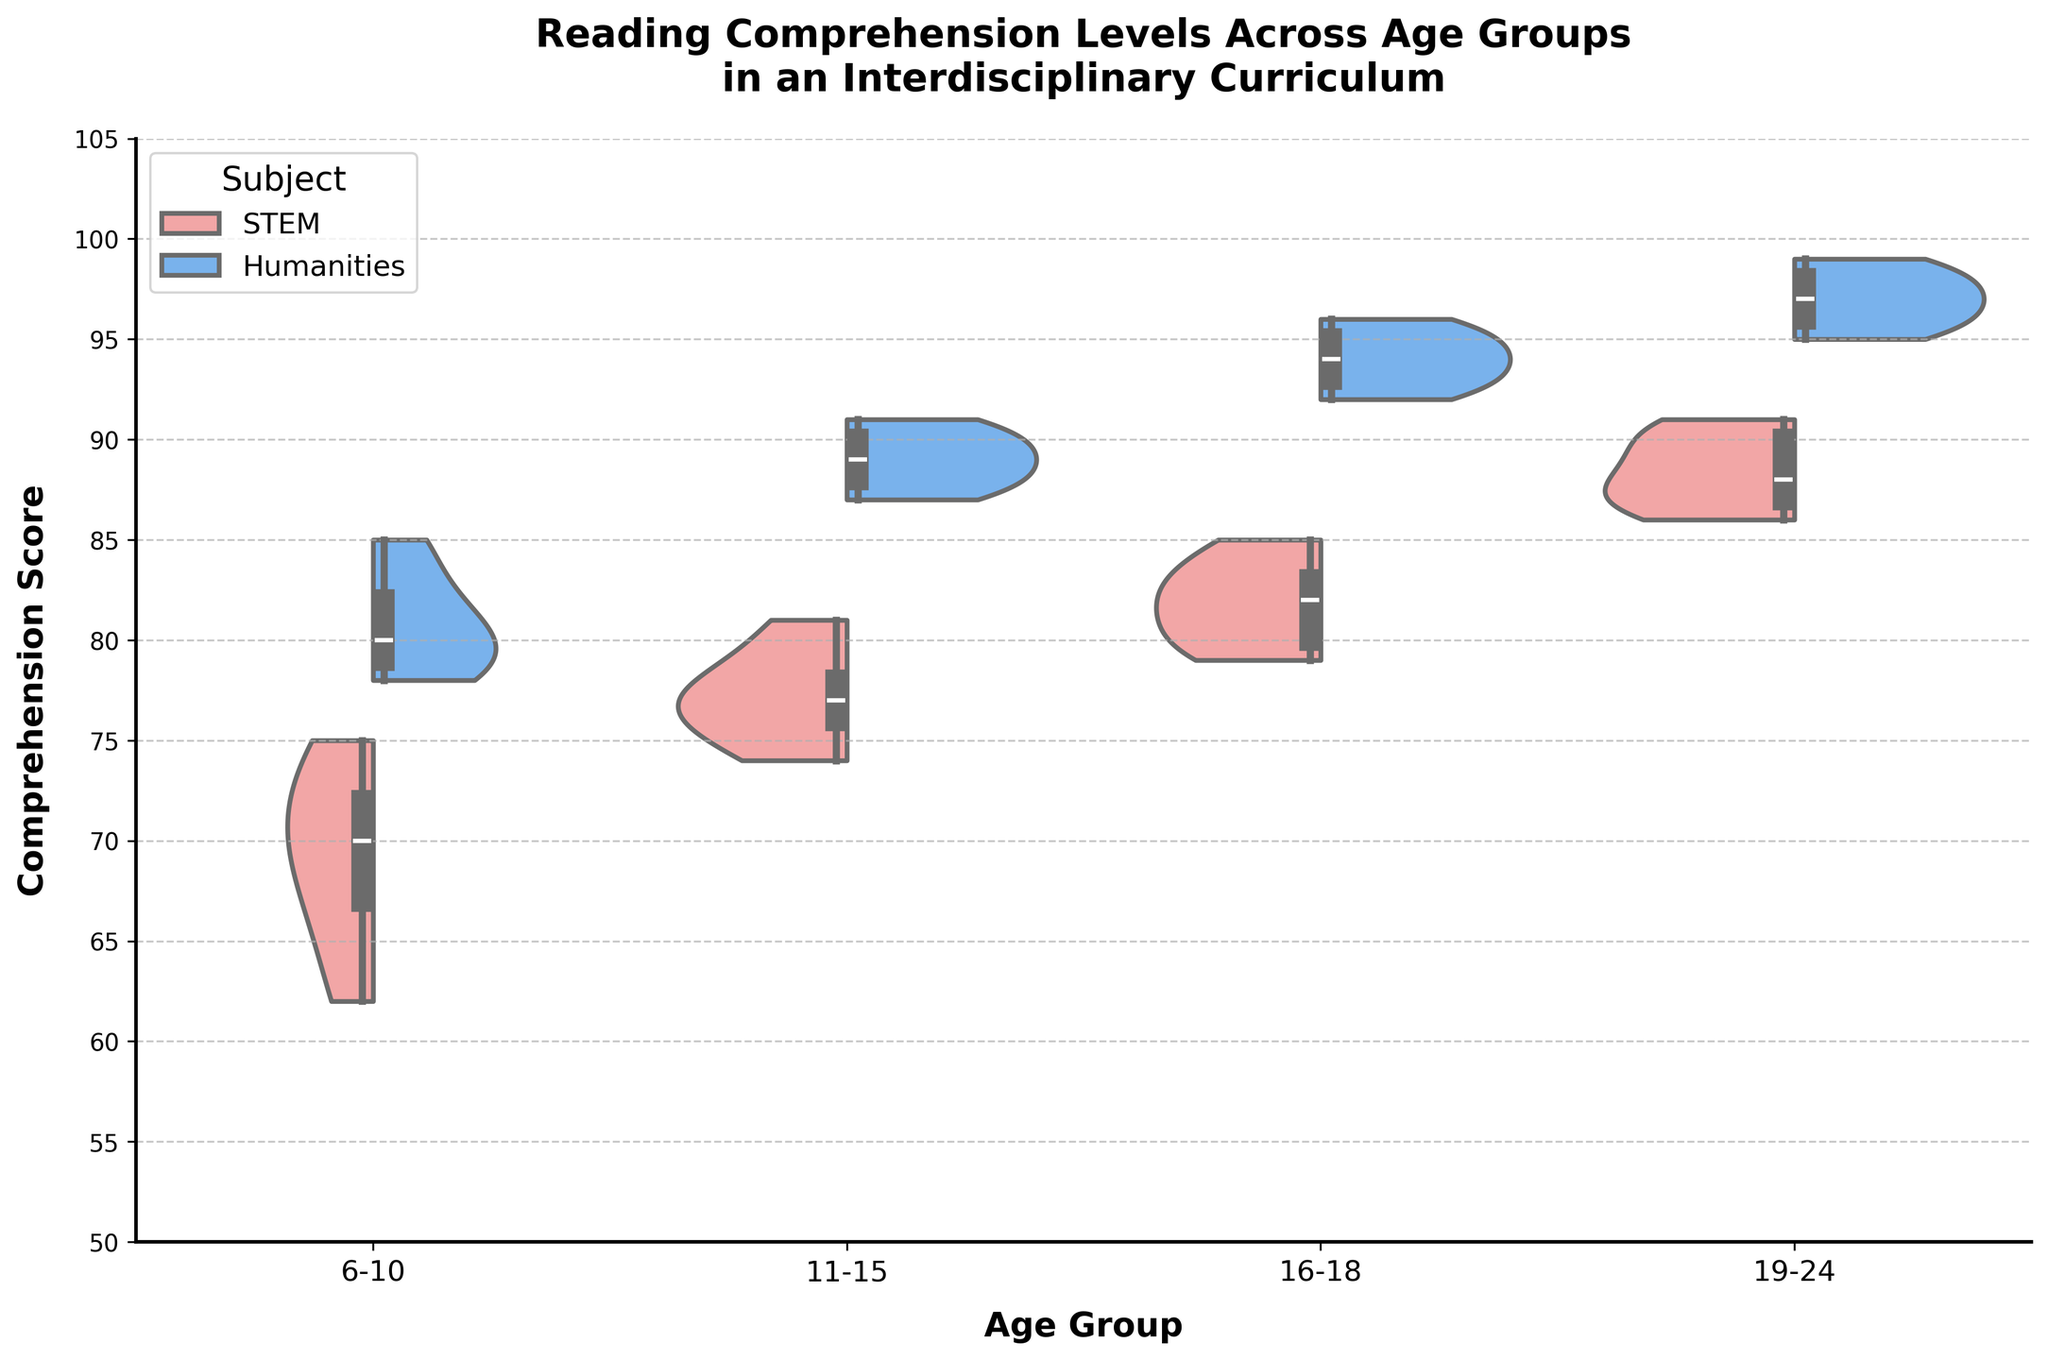What is the range of comprehension scores for the 6-10 age group in STEM subjects? The range is calculated by subtracting the minimum score from the maximum score. For the 6-10 age group in STEM subjects, the minimum score is 62 and the maximum score is 75. So, the range is 75 - 62 = 13.
Answer: 13 Which subject has a higher median comprehension score in the 11-15 age group? By observing the boxplots within the violin plots, the line in the boxplot representing the median score for Humanities is higher compared to STEM for the 11-15 age group.
Answer: Humanities Are the comprehension scores for the 16-18 age group more spread out in STEM or Humanities? By examining the width of the violin plots, the STEM scores appear to have a wider distribution, indicating they are more spread out in the 16-18 age group compared to Humanities scores.
Answer: STEM What is the overall trend in comprehension scores for Humanities subjects as age increases? By looking at the box plots and the overall shape of the violin plots, we can see that the median comprehension scores for Humanities subjects increase as age increases from 6-10 to 19-24.
Answer: Increase How does the comprehension score distribution for STEM subjects in the 19-24 age group compare to the 16-18 age group? The violin plot with box plot overlay shows that for the 19-24 age group, the scores are less spread out and have higher median scores compared to the 16-18 age group.
Answer: Less spread out and higher median What is the interquartile range (IQR) for Humanities comprehension scores in the 19-24 age group? The IQR is the range between the first quartile (Q1) and the third quartile (Q3). For the 19-24 Humanities group, Q1 is about 95, and Q3 is about 98. So, the IQR is 98 - 95 = 3.
Answer: 3 Which age group shows the least variability in comprehension scores for Humanities? By comparing the widths and spreads of the violin plots for Humanities scores across different age groups, the 19-24 age group shows the least variability, as indicated by its narrower distribution.
Answer: 19-24 What is the biggest difference between comprehension scores in Humanities and STEM for any age group? To find the biggest difference, compare the maximum values of Humanities and STEM for all age groups. The largest gap is observed for the 19-24 age group where the maximum scores are 99 for Humanities and 91 for STEM, giving a difference of 8 points.
Answer: 8 Which subject has more evenly distributed scores in the 6-10 age group? By examining the violin plots, Humanities shows a more even distribution of scores in the 6-10 age group compared to STEM.
Answer: Humanities 